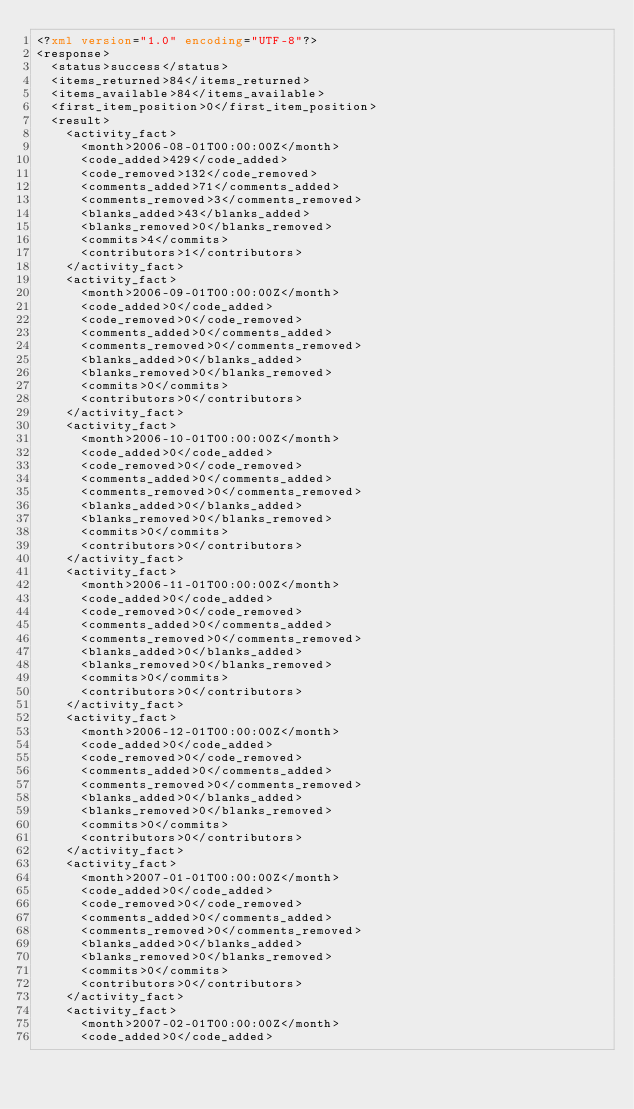Convert code to text. <code><loc_0><loc_0><loc_500><loc_500><_XML_><?xml version="1.0" encoding="UTF-8"?>
<response>
  <status>success</status>
  <items_returned>84</items_returned>
  <items_available>84</items_available>
  <first_item_position>0</first_item_position>
  <result>
    <activity_fact>
      <month>2006-08-01T00:00:00Z</month>
      <code_added>429</code_added>
      <code_removed>132</code_removed>
      <comments_added>71</comments_added>
      <comments_removed>3</comments_removed>
      <blanks_added>43</blanks_added>
      <blanks_removed>0</blanks_removed>
      <commits>4</commits>
      <contributors>1</contributors>
    </activity_fact>
    <activity_fact>
      <month>2006-09-01T00:00:00Z</month>
      <code_added>0</code_added>
      <code_removed>0</code_removed>
      <comments_added>0</comments_added>
      <comments_removed>0</comments_removed>
      <blanks_added>0</blanks_added>
      <blanks_removed>0</blanks_removed>
      <commits>0</commits>
      <contributors>0</contributors>
    </activity_fact>
    <activity_fact>
      <month>2006-10-01T00:00:00Z</month>
      <code_added>0</code_added>
      <code_removed>0</code_removed>
      <comments_added>0</comments_added>
      <comments_removed>0</comments_removed>
      <blanks_added>0</blanks_added>
      <blanks_removed>0</blanks_removed>
      <commits>0</commits>
      <contributors>0</contributors>
    </activity_fact>
    <activity_fact>
      <month>2006-11-01T00:00:00Z</month>
      <code_added>0</code_added>
      <code_removed>0</code_removed>
      <comments_added>0</comments_added>
      <comments_removed>0</comments_removed>
      <blanks_added>0</blanks_added>
      <blanks_removed>0</blanks_removed>
      <commits>0</commits>
      <contributors>0</contributors>
    </activity_fact>
    <activity_fact>
      <month>2006-12-01T00:00:00Z</month>
      <code_added>0</code_added>
      <code_removed>0</code_removed>
      <comments_added>0</comments_added>
      <comments_removed>0</comments_removed>
      <blanks_added>0</blanks_added>
      <blanks_removed>0</blanks_removed>
      <commits>0</commits>
      <contributors>0</contributors>
    </activity_fact>
    <activity_fact>
      <month>2007-01-01T00:00:00Z</month>
      <code_added>0</code_added>
      <code_removed>0</code_removed>
      <comments_added>0</comments_added>
      <comments_removed>0</comments_removed>
      <blanks_added>0</blanks_added>
      <blanks_removed>0</blanks_removed>
      <commits>0</commits>
      <contributors>0</contributors>
    </activity_fact>
    <activity_fact>
      <month>2007-02-01T00:00:00Z</month>
      <code_added>0</code_added></code> 